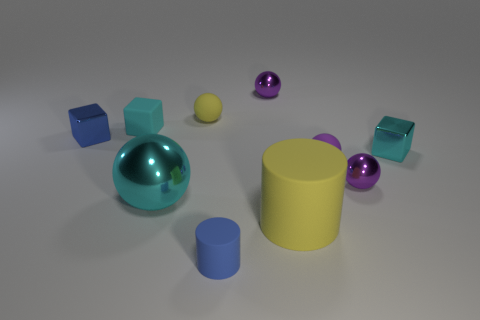How many other objects are there of the same color as the large rubber cylinder?
Keep it short and to the point. 1. How many cyan objects are either tiny things or large spheres?
Your answer should be very brief. 3. Is the shape of the big cyan object the same as the purple thing that is left of the yellow cylinder?
Your answer should be compact. Yes. The blue metallic object is what shape?
Give a very brief answer. Cube. What material is the blue block that is the same size as the purple matte ball?
Provide a short and direct response. Metal. What number of things are large matte cylinders or tiny rubber objects behind the large cyan metal object?
Offer a terse response. 4. The purple object that is the same material as the small cylinder is what size?
Offer a very short reply. Small. The yellow rubber object that is behind the cyan cube right of the tiny yellow rubber thing is what shape?
Keep it short and to the point. Sphere. There is a metallic thing that is both to the left of the blue matte cylinder and on the right side of the tiny blue shiny cube; what size is it?
Your answer should be very brief. Large. Are there any blue objects that have the same shape as the large yellow thing?
Your answer should be compact. Yes. 